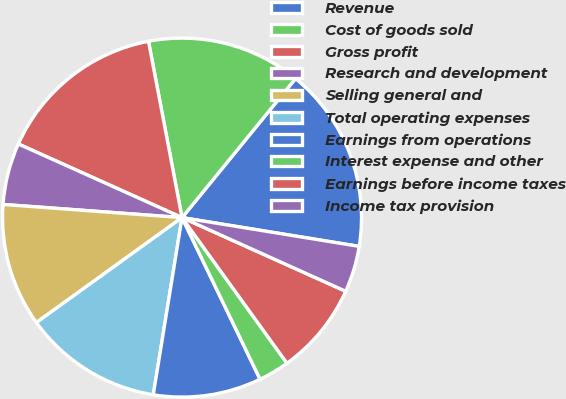Convert chart. <chart><loc_0><loc_0><loc_500><loc_500><pie_chart><fcel>Revenue<fcel>Cost of goods sold<fcel>Gross profit<fcel>Research and development<fcel>Selling general and<fcel>Total operating expenses<fcel>Earnings from operations<fcel>Interest expense and other<fcel>Earnings before income taxes<fcel>Income tax provision<nl><fcel>16.67%<fcel>13.89%<fcel>15.28%<fcel>5.56%<fcel>11.11%<fcel>12.5%<fcel>9.72%<fcel>2.78%<fcel>8.33%<fcel>4.17%<nl></chart> 